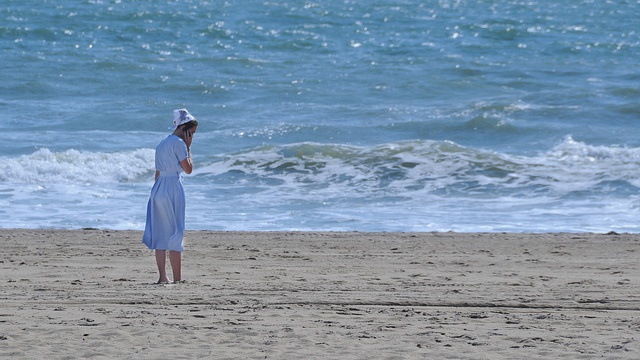Describe the objects in this image and their specific colors. I can see people in gray and darkgray tones and cell phone in black, purple, and gray tones in this image. 